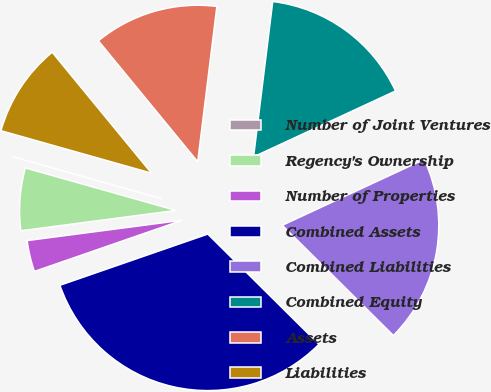<chart> <loc_0><loc_0><loc_500><loc_500><pie_chart><fcel>Number of Joint Ventures<fcel>Regency's Ownership<fcel>Number of Properties<fcel>Combined Assets<fcel>Combined Liabilities<fcel>Combined Equity<fcel>Assets<fcel>Liabilities<nl><fcel>0.0%<fcel>6.45%<fcel>3.23%<fcel>32.26%<fcel>19.35%<fcel>16.13%<fcel>12.9%<fcel>9.68%<nl></chart> 